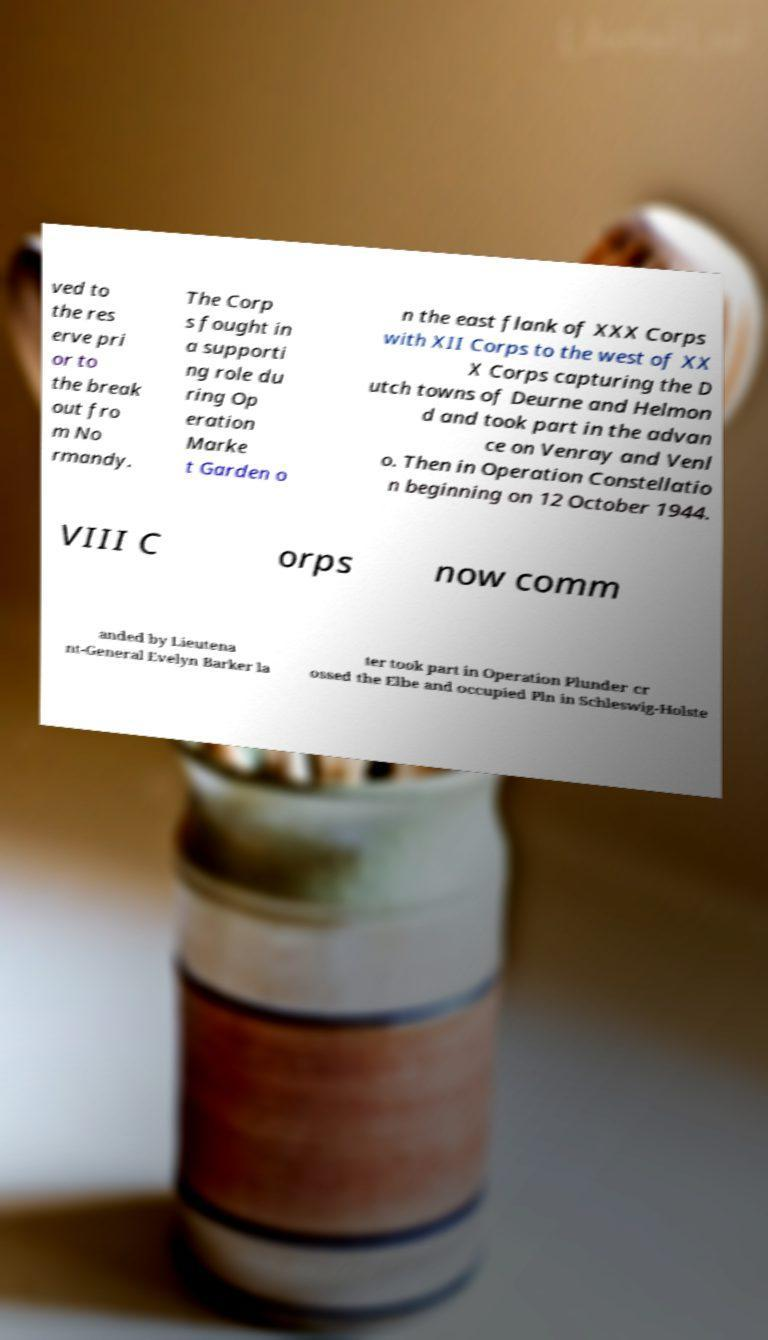What messages or text are displayed in this image? I need them in a readable, typed format. ved to the res erve pri or to the break out fro m No rmandy. The Corp s fought in a supporti ng role du ring Op eration Marke t Garden o n the east flank of XXX Corps with XII Corps to the west of XX X Corps capturing the D utch towns of Deurne and Helmon d and took part in the advan ce on Venray and Venl o. Then in Operation Constellatio n beginning on 12 October 1944. VIII C orps now comm anded by Lieutena nt-General Evelyn Barker la ter took part in Operation Plunder cr ossed the Elbe and occupied Pln in Schleswig-Holste 